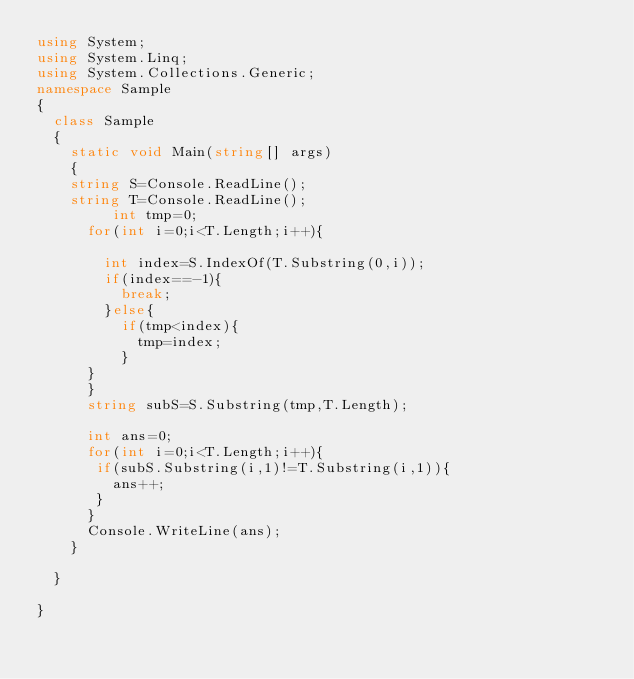Convert code to text. <code><loc_0><loc_0><loc_500><loc_500><_C#_>using System;
using System.Linq;
using System.Collections.Generic;
namespace Sample
{
  class Sample
  {
    static void Main(string[] args)
    {
    string S=Console.ReadLine();
    string T=Console.ReadLine();
         int tmp=0;
      for(int i=0;i<T.Length;i++){
     
        int index=S.IndexOf(T.Substring(0,i));
        if(index==-1){
          break;
        }else{
          if(tmp<index){
            tmp=index;
          }         
      }
      }
      string subS=S.Substring(tmp,T.Length);
      
      int ans=0;
      for(int i=0;i<T.Length;i++){
       if(subS.Substring(i,1)!=T.Substring(i,1)){
         ans++;
       }
      }
      Console.WriteLine(ans);
    }
    
  }

}
</code> 